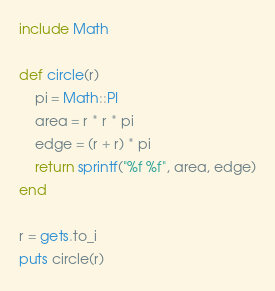<code> <loc_0><loc_0><loc_500><loc_500><_Ruby_>include Math

def circle(r)
	pi = Math::PI
	area = r * r * pi
	edge = (r + r) * pi
	return sprintf("%f %f", area, edge)
end

r = gets.to_i
puts circle(r)</code> 